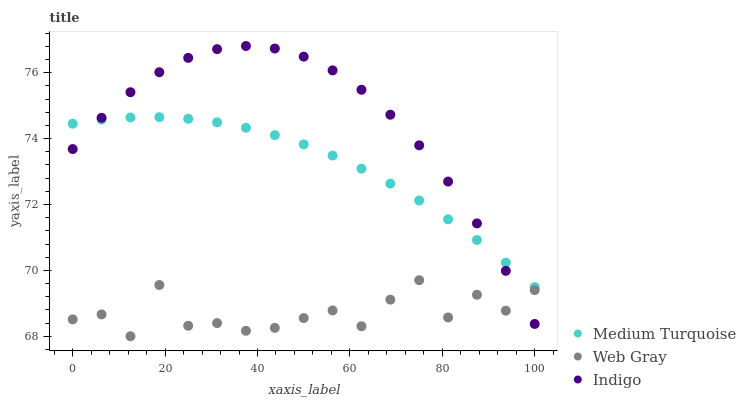Does Web Gray have the minimum area under the curve?
Answer yes or no. Yes. Does Indigo have the maximum area under the curve?
Answer yes or no. Yes. Does Medium Turquoise have the minimum area under the curve?
Answer yes or no. No. Does Medium Turquoise have the maximum area under the curve?
Answer yes or no. No. Is Medium Turquoise the smoothest?
Answer yes or no. Yes. Is Web Gray the roughest?
Answer yes or no. Yes. Is Indigo the smoothest?
Answer yes or no. No. Is Indigo the roughest?
Answer yes or no. No. Does Web Gray have the lowest value?
Answer yes or no. Yes. Does Indigo have the lowest value?
Answer yes or no. No. Does Indigo have the highest value?
Answer yes or no. Yes. Does Medium Turquoise have the highest value?
Answer yes or no. No. Is Web Gray less than Medium Turquoise?
Answer yes or no. Yes. Is Medium Turquoise greater than Web Gray?
Answer yes or no. Yes. Does Medium Turquoise intersect Indigo?
Answer yes or no. Yes. Is Medium Turquoise less than Indigo?
Answer yes or no. No. Is Medium Turquoise greater than Indigo?
Answer yes or no. No. Does Web Gray intersect Medium Turquoise?
Answer yes or no. No. 